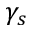Convert formula to latex. <formula><loc_0><loc_0><loc_500><loc_500>\gamma _ { s }</formula> 